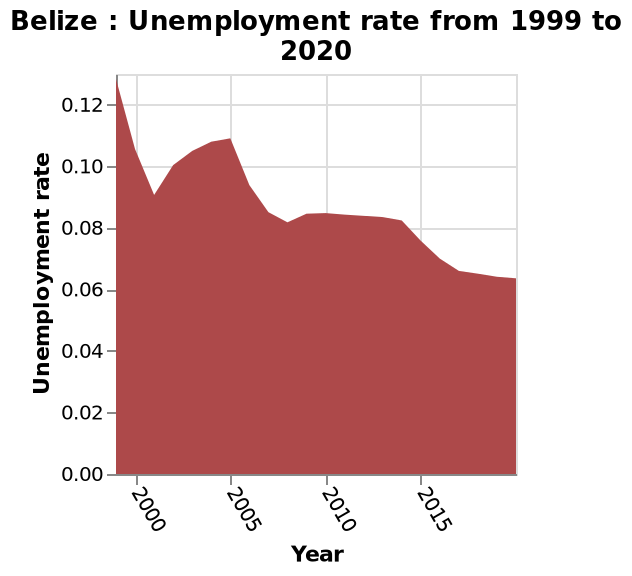<image>
Was there a period of slight increase in the unemployment rate?  Yes, there was a slight increase in the unemployment rate over 2005. How is the year represented on the x-axis of the area diagram? The year is shown as a linear scale from 2000 to 2015 on the x-axis. What is the time range covered by the unemployment rate area diagram? The unemployment rate area diagram covers the period from 1999 to 2020. 